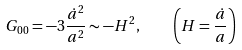<formula> <loc_0><loc_0><loc_500><loc_500>G _ { 0 0 } = - 3 \frac { \dot { a } ^ { 2 } } { a ^ { 2 } } \sim - H ^ { 2 } , \quad \left ( H = \frac { \dot { a } } { a } \right )</formula> 